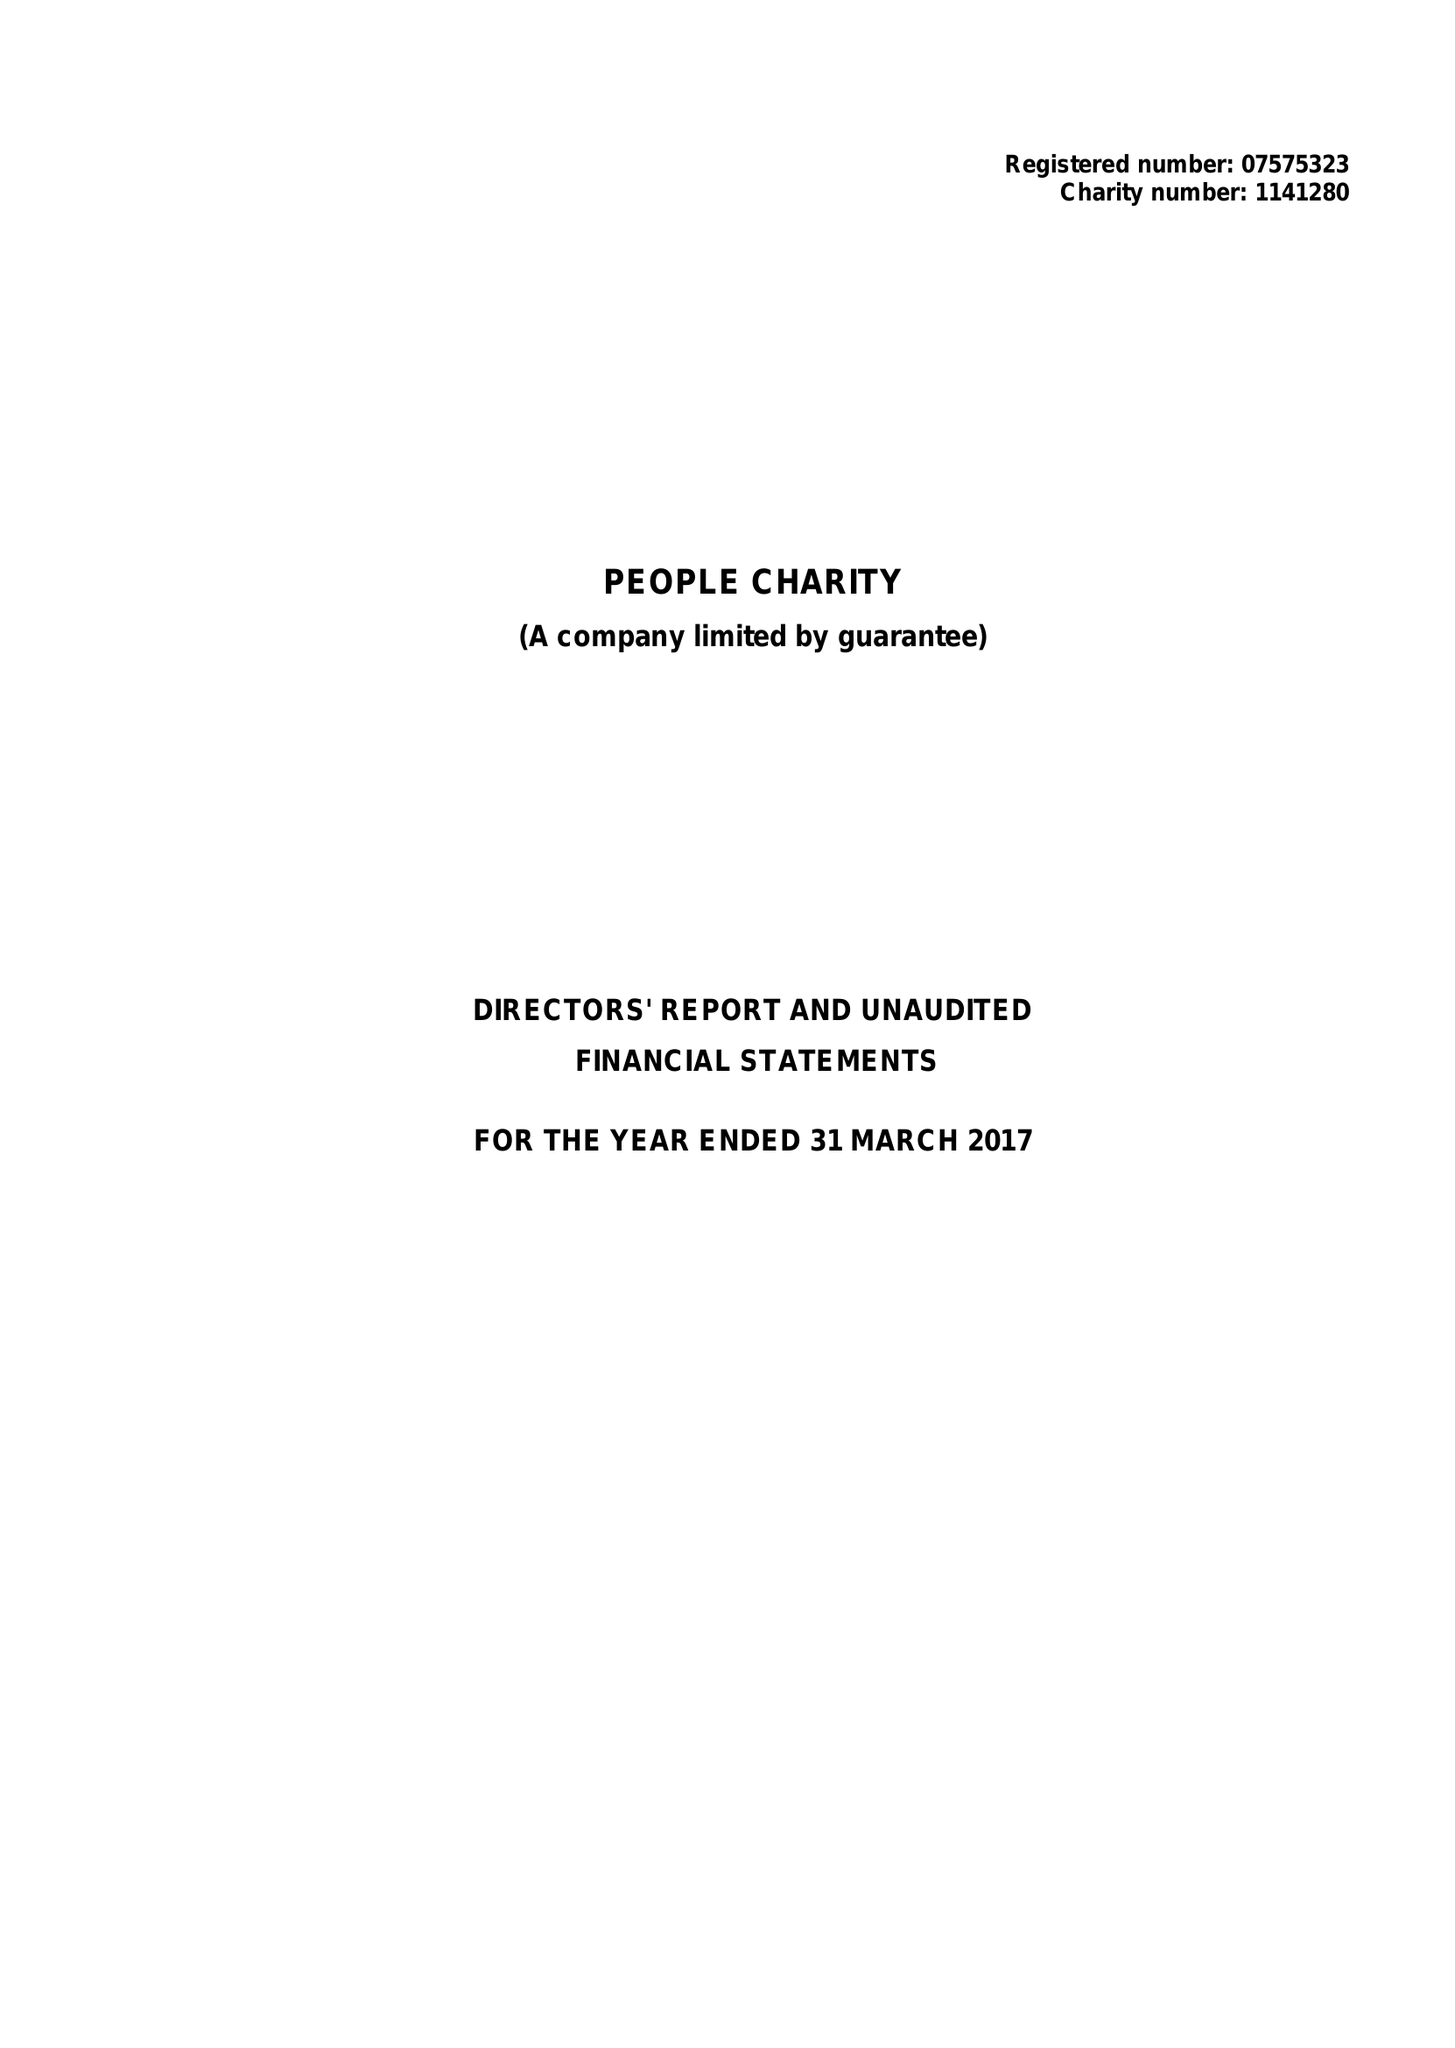What is the value for the spending_annually_in_british_pounds?
Answer the question using a single word or phrase. 34514.00 